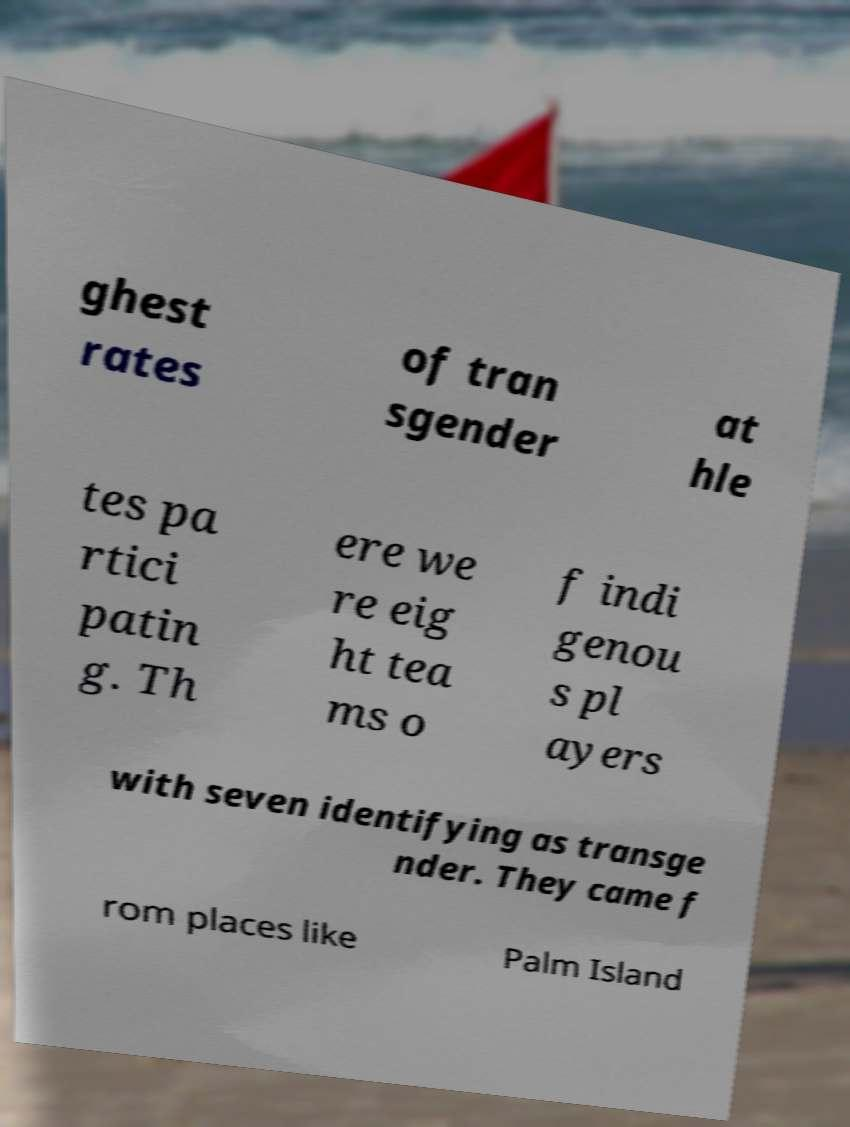Could you extract and type out the text from this image? ghest rates of tran sgender at hle tes pa rtici patin g. Th ere we re eig ht tea ms o f indi genou s pl ayers with seven identifying as transge nder. They came f rom places like Palm Island 